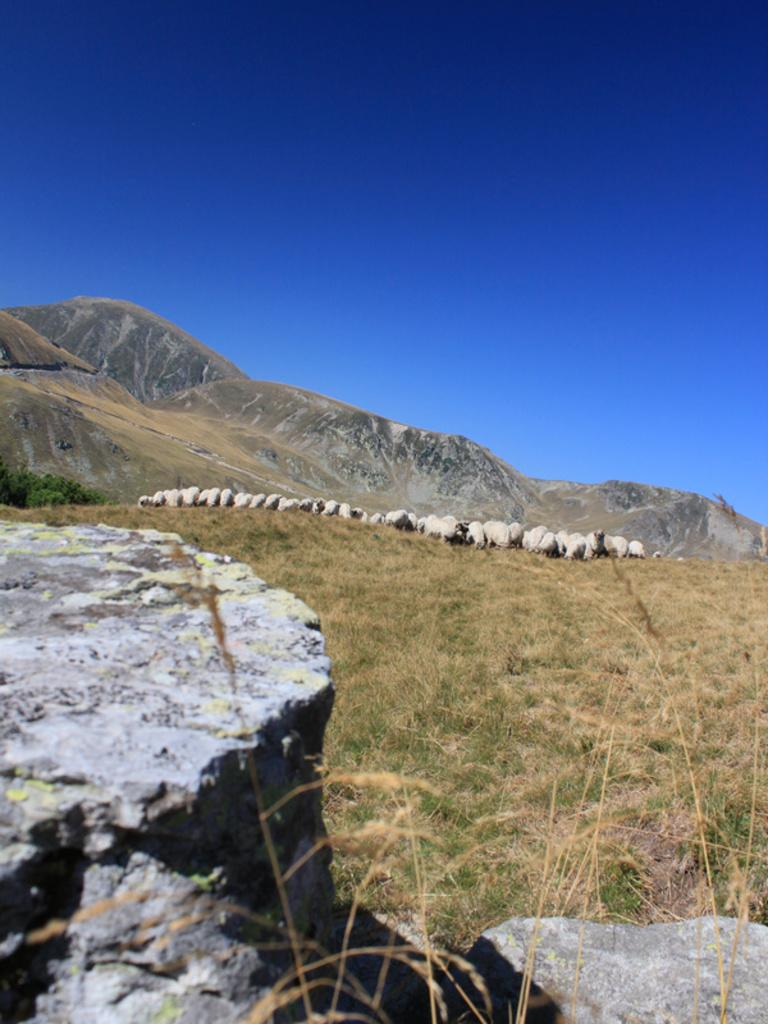What animals are in the center of the image? There are sheep in the center of the image. What type of terrain are the sheep on? The sheep are on a grassland. What other objects can be seen in the image? There are rocks in the image. What is visible in the background of the image? The sky is visible in the image. Can you tell me how many cobwebs are present in the image? There are no cobwebs present in the image; it features sheep on a grassland with rocks and a visible sky. 